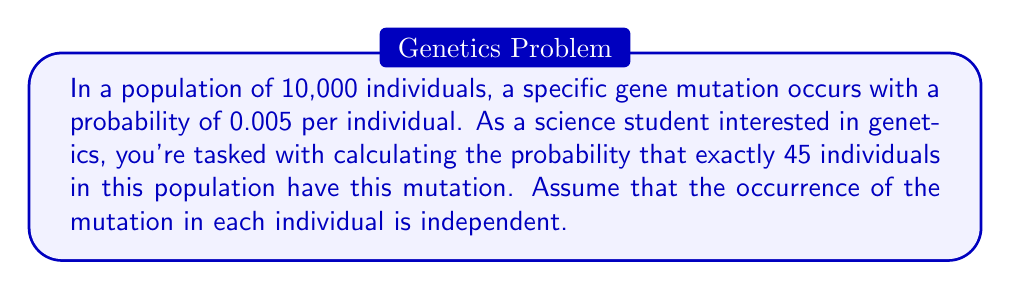Help me with this question. To solve this problem, we'll use the binomial probability distribution, as we're dealing with a fixed number of independent trials (individuals) with two possible outcomes (mutation or no mutation).

1. Identify the parameters:
   - $n$ = 10,000 (number of individuals)
   - $p$ = 0.005 (probability of mutation for each individual)
   - $k$ = 45 (number of individuals with the mutation we're interested in)

2. The binomial probability formula is:

   $$ P(X = k) = \binom{n}{k} p^k (1-p)^{n-k} $$

   Where $\binom{n}{k}$ is the binomial coefficient, calculated as:

   $$ \binom{n}{k} = \frac{n!}{k!(n-k)!} $$

3. Calculate the binomial coefficient:
   
   $$ \binom{10000}{45} = \frac{10000!}{45!(10000-45)!} = \frac{10000!}{45!9955!} $$

4. Substitute the values into the binomial probability formula:

   $$ P(X = 45) = \binom{10000}{45} (0.005)^{45} (1-0.005)^{10000-45} $$

5. Simplify:

   $$ P(X = 45) = \binom{10000}{45} (0.005)^{45} (0.995)^{9955} $$

6. Use a calculator or computer to evaluate this expression, as the numbers involved are very large.

The result of this calculation gives us the probability of exactly 45 individuals having the mutation in the population of 10,000.
Answer: The probability of exactly 45 individuals having the specific gene mutation in a population of 10,000 is approximately $0.0549$ or $5.49\%$. 